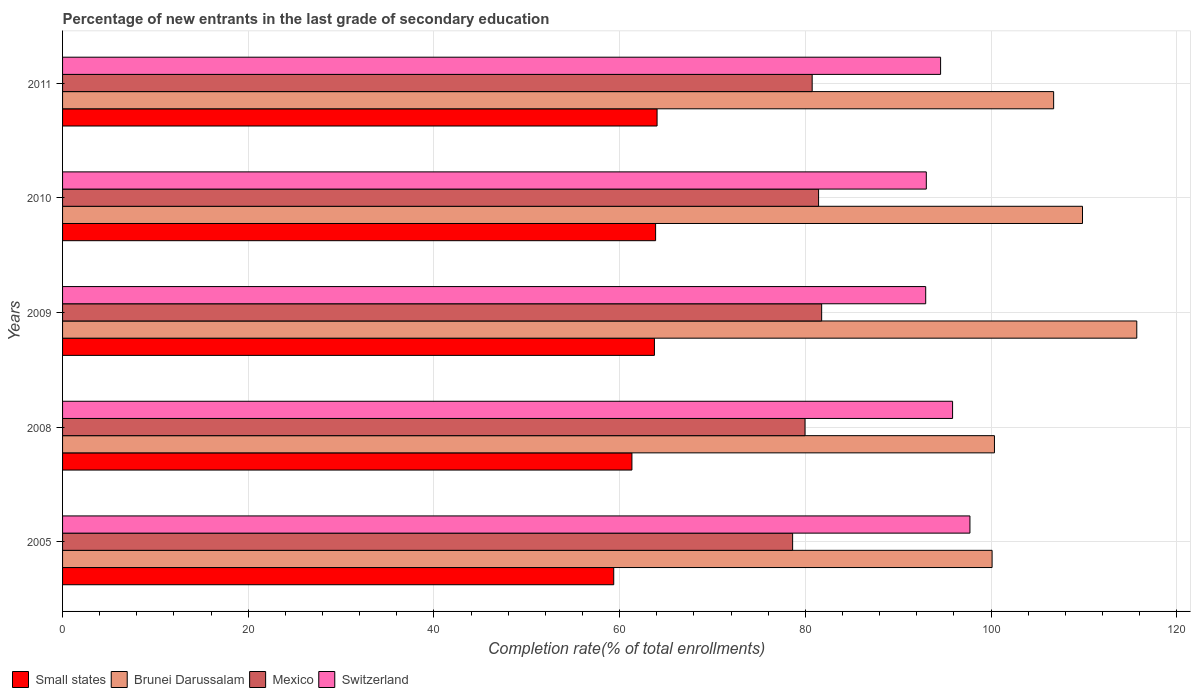How many groups of bars are there?
Give a very brief answer. 5. Are the number of bars on each tick of the Y-axis equal?
Your answer should be very brief. Yes. How many bars are there on the 1st tick from the top?
Your answer should be compact. 4. What is the label of the 3rd group of bars from the top?
Provide a short and direct response. 2009. What is the percentage of new entrants in Small states in 2011?
Your response must be concise. 64.03. Across all years, what is the maximum percentage of new entrants in Brunei Darussalam?
Give a very brief answer. 115.7. Across all years, what is the minimum percentage of new entrants in Switzerland?
Provide a short and direct response. 92.97. In which year was the percentage of new entrants in Switzerland maximum?
Ensure brevity in your answer.  2005. In which year was the percentage of new entrants in Switzerland minimum?
Keep it short and to the point. 2009. What is the total percentage of new entrants in Mexico in the graph?
Your answer should be very brief. 402.53. What is the difference between the percentage of new entrants in Switzerland in 2008 and that in 2011?
Your answer should be compact. 1.29. What is the difference between the percentage of new entrants in Switzerland in 2010 and the percentage of new entrants in Mexico in 2011?
Give a very brief answer. 12.29. What is the average percentage of new entrants in Small states per year?
Ensure brevity in your answer.  62.47. In the year 2009, what is the difference between the percentage of new entrants in Small states and percentage of new entrants in Brunei Darussalam?
Keep it short and to the point. -51.95. What is the ratio of the percentage of new entrants in Small states in 2009 to that in 2010?
Offer a very short reply. 1. Is the difference between the percentage of new entrants in Small states in 2005 and 2008 greater than the difference between the percentage of new entrants in Brunei Darussalam in 2005 and 2008?
Make the answer very short. No. What is the difference between the highest and the second highest percentage of new entrants in Switzerland?
Offer a very short reply. 1.87. What is the difference between the highest and the lowest percentage of new entrants in Small states?
Your answer should be compact. 4.67. In how many years, is the percentage of new entrants in Switzerland greater than the average percentage of new entrants in Switzerland taken over all years?
Ensure brevity in your answer.  2. Is the sum of the percentage of new entrants in Small states in 2009 and 2011 greater than the maximum percentage of new entrants in Switzerland across all years?
Offer a terse response. Yes. What does the 1st bar from the top in 2008 represents?
Offer a terse response. Switzerland. How many bars are there?
Your answer should be very brief. 20. Are all the bars in the graph horizontal?
Ensure brevity in your answer.  Yes. How many years are there in the graph?
Provide a succinct answer. 5. Are the values on the major ticks of X-axis written in scientific E-notation?
Your response must be concise. No. Does the graph contain any zero values?
Offer a terse response. No. Does the graph contain grids?
Offer a very short reply. Yes. How many legend labels are there?
Make the answer very short. 4. How are the legend labels stacked?
Ensure brevity in your answer.  Horizontal. What is the title of the graph?
Provide a succinct answer. Percentage of new entrants in the last grade of secondary education. What is the label or title of the X-axis?
Offer a very short reply. Completion rate(% of total enrollments). What is the Completion rate(% of total enrollments) in Small states in 2005?
Your answer should be compact. 59.36. What is the Completion rate(% of total enrollments) in Brunei Darussalam in 2005?
Your answer should be very brief. 100.12. What is the Completion rate(% of total enrollments) of Mexico in 2005?
Your response must be concise. 78.63. What is the Completion rate(% of total enrollments) of Switzerland in 2005?
Provide a succinct answer. 97.73. What is the Completion rate(% of total enrollments) in Small states in 2008?
Your response must be concise. 61.32. What is the Completion rate(% of total enrollments) in Brunei Darussalam in 2008?
Offer a very short reply. 100.37. What is the Completion rate(% of total enrollments) in Mexico in 2008?
Make the answer very short. 79.97. What is the Completion rate(% of total enrollments) of Switzerland in 2008?
Your answer should be compact. 95.86. What is the Completion rate(% of total enrollments) in Small states in 2009?
Your answer should be very brief. 63.75. What is the Completion rate(% of total enrollments) in Brunei Darussalam in 2009?
Make the answer very short. 115.7. What is the Completion rate(% of total enrollments) in Mexico in 2009?
Your answer should be very brief. 81.76. What is the Completion rate(% of total enrollments) in Switzerland in 2009?
Give a very brief answer. 92.97. What is the Completion rate(% of total enrollments) in Small states in 2010?
Make the answer very short. 63.88. What is the Completion rate(% of total enrollments) in Brunei Darussalam in 2010?
Offer a terse response. 109.86. What is the Completion rate(% of total enrollments) in Mexico in 2010?
Offer a very short reply. 81.43. What is the Completion rate(% of total enrollments) in Switzerland in 2010?
Your response must be concise. 93.03. What is the Completion rate(% of total enrollments) in Small states in 2011?
Provide a short and direct response. 64.03. What is the Completion rate(% of total enrollments) of Brunei Darussalam in 2011?
Give a very brief answer. 106.75. What is the Completion rate(% of total enrollments) of Mexico in 2011?
Provide a short and direct response. 80.74. What is the Completion rate(% of total enrollments) of Switzerland in 2011?
Give a very brief answer. 94.57. Across all years, what is the maximum Completion rate(% of total enrollments) in Small states?
Make the answer very short. 64.03. Across all years, what is the maximum Completion rate(% of total enrollments) in Brunei Darussalam?
Make the answer very short. 115.7. Across all years, what is the maximum Completion rate(% of total enrollments) in Mexico?
Your answer should be very brief. 81.76. Across all years, what is the maximum Completion rate(% of total enrollments) of Switzerland?
Your answer should be very brief. 97.73. Across all years, what is the minimum Completion rate(% of total enrollments) in Small states?
Your response must be concise. 59.36. Across all years, what is the minimum Completion rate(% of total enrollments) of Brunei Darussalam?
Offer a terse response. 100.12. Across all years, what is the minimum Completion rate(% of total enrollments) in Mexico?
Your answer should be compact. 78.63. Across all years, what is the minimum Completion rate(% of total enrollments) in Switzerland?
Provide a succinct answer. 92.97. What is the total Completion rate(% of total enrollments) in Small states in the graph?
Keep it short and to the point. 312.35. What is the total Completion rate(% of total enrollments) in Brunei Darussalam in the graph?
Provide a short and direct response. 532.79. What is the total Completion rate(% of total enrollments) of Mexico in the graph?
Keep it short and to the point. 402.53. What is the total Completion rate(% of total enrollments) of Switzerland in the graph?
Provide a succinct answer. 474.16. What is the difference between the Completion rate(% of total enrollments) of Small states in 2005 and that in 2008?
Provide a succinct answer. -1.96. What is the difference between the Completion rate(% of total enrollments) of Brunei Darussalam in 2005 and that in 2008?
Give a very brief answer. -0.25. What is the difference between the Completion rate(% of total enrollments) in Mexico in 2005 and that in 2008?
Provide a succinct answer. -1.34. What is the difference between the Completion rate(% of total enrollments) of Switzerland in 2005 and that in 2008?
Provide a succinct answer. 1.87. What is the difference between the Completion rate(% of total enrollments) in Small states in 2005 and that in 2009?
Offer a terse response. -4.38. What is the difference between the Completion rate(% of total enrollments) in Brunei Darussalam in 2005 and that in 2009?
Give a very brief answer. -15.58. What is the difference between the Completion rate(% of total enrollments) in Mexico in 2005 and that in 2009?
Keep it short and to the point. -3.13. What is the difference between the Completion rate(% of total enrollments) in Switzerland in 2005 and that in 2009?
Keep it short and to the point. 4.76. What is the difference between the Completion rate(% of total enrollments) in Small states in 2005 and that in 2010?
Make the answer very short. -4.51. What is the difference between the Completion rate(% of total enrollments) in Brunei Darussalam in 2005 and that in 2010?
Provide a succinct answer. -9.74. What is the difference between the Completion rate(% of total enrollments) in Mexico in 2005 and that in 2010?
Give a very brief answer. -2.8. What is the difference between the Completion rate(% of total enrollments) in Switzerland in 2005 and that in 2010?
Offer a very short reply. 4.7. What is the difference between the Completion rate(% of total enrollments) in Small states in 2005 and that in 2011?
Provide a succinct answer. -4.67. What is the difference between the Completion rate(% of total enrollments) of Brunei Darussalam in 2005 and that in 2011?
Your answer should be compact. -6.63. What is the difference between the Completion rate(% of total enrollments) in Mexico in 2005 and that in 2011?
Provide a succinct answer. -2.11. What is the difference between the Completion rate(% of total enrollments) in Switzerland in 2005 and that in 2011?
Offer a terse response. 3.16. What is the difference between the Completion rate(% of total enrollments) of Small states in 2008 and that in 2009?
Keep it short and to the point. -2.42. What is the difference between the Completion rate(% of total enrollments) of Brunei Darussalam in 2008 and that in 2009?
Offer a very short reply. -15.33. What is the difference between the Completion rate(% of total enrollments) of Mexico in 2008 and that in 2009?
Your answer should be very brief. -1.79. What is the difference between the Completion rate(% of total enrollments) in Switzerland in 2008 and that in 2009?
Ensure brevity in your answer.  2.9. What is the difference between the Completion rate(% of total enrollments) of Small states in 2008 and that in 2010?
Your response must be concise. -2.55. What is the difference between the Completion rate(% of total enrollments) of Brunei Darussalam in 2008 and that in 2010?
Make the answer very short. -9.48. What is the difference between the Completion rate(% of total enrollments) in Mexico in 2008 and that in 2010?
Your answer should be very brief. -1.46. What is the difference between the Completion rate(% of total enrollments) of Switzerland in 2008 and that in 2010?
Your answer should be very brief. 2.83. What is the difference between the Completion rate(% of total enrollments) of Small states in 2008 and that in 2011?
Provide a succinct answer. -2.71. What is the difference between the Completion rate(% of total enrollments) in Brunei Darussalam in 2008 and that in 2011?
Offer a terse response. -6.38. What is the difference between the Completion rate(% of total enrollments) in Mexico in 2008 and that in 2011?
Your answer should be compact. -0.77. What is the difference between the Completion rate(% of total enrollments) in Switzerland in 2008 and that in 2011?
Provide a succinct answer. 1.29. What is the difference between the Completion rate(% of total enrollments) in Small states in 2009 and that in 2010?
Your response must be concise. -0.13. What is the difference between the Completion rate(% of total enrollments) of Brunei Darussalam in 2009 and that in 2010?
Your answer should be compact. 5.85. What is the difference between the Completion rate(% of total enrollments) of Mexico in 2009 and that in 2010?
Keep it short and to the point. 0.33. What is the difference between the Completion rate(% of total enrollments) of Switzerland in 2009 and that in 2010?
Provide a succinct answer. -0.07. What is the difference between the Completion rate(% of total enrollments) of Small states in 2009 and that in 2011?
Keep it short and to the point. -0.28. What is the difference between the Completion rate(% of total enrollments) of Brunei Darussalam in 2009 and that in 2011?
Your response must be concise. 8.95. What is the difference between the Completion rate(% of total enrollments) of Mexico in 2009 and that in 2011?
Ensure brevity in your answer.  1.02. What is the difference between the Completion rate(% of total enrollments) in Switzerland in 2009 and that in 2011?
Keep it short and to the point. -1.61. What is the difference between the Completion rate(% of total enrollments) of Small states in 2010 and that in 2011?
Provide a succinct answer. -0.16. What is the difference between the Completion rate(% of total enrollments) of Brunei Darussalam in 2010 and that in 2011?
Offer a terse response. 3.11. What is the difference between the Completion rate(% of total enrollments) of Mexico in 2010 and that in 2011?
Provide a succinct answer. 0.69. What is the difference between the Completion rate(% of total enrollments) in Switzerland in 2010 and that in 2011?
Offer a terse response. -1.54. What is the difference between the Completion rate(% of total enrollments) of Small states in 2005 and the Completion rate(% of total enrollments) of Brunei Darussalam in 2008?
Provide a succinct answer. -41.01. What is the difference between the Completion rate(% of total enrollments) of Small states in 2005 and the Completion rate(% of total enrollments) of Mexico in 2008?
Offer a terse response. -20.6. What is the difference between the Completion rate(% of total enrollments) of Small states in 2005 and the Completion rate(% of total enrollments) of Switzerland in 2008?
Keep it short and to the point. -36.5. What is the difference between the Completion rate(% of total enrollments) in Brunei Darussalam in 2005 and the Completion rate(% of total enrollments) in Mexico in 2008?
Your response must be concise. 20.15. What is the difference between the Completion rate(% of total enrollments) of Brunei Darussalam in 2005 and the Completion rate(% of total enrollments) of Switzerland in 2008?
Provide a succinct answer. 4.26. What is the difference between the Completion rate(% of total enrollments) of Mexico in 2005 and the Completion rate(% of total enrollments) of Switzerland in 2008?
Offer a terse response. -17.23. What is the difference between the Completion rate(% of total enrollments) in Small states in 2005 and the Completion rate(% of total enrollments) in Brunei Darussalam in 2009?
Provide a succinct answer. -56.34. What is the difference between the Completion rate(% of total enrollments) in Small states in 2005 and the Completion rate(% of total enrollments) in Mexico in 2009?
Provide a short and direct response. -22.4. What is the difference between the Completion rate(% of total enrollments) in Small states in 2005 and the Completion rate(% of total enrollments) in Switzerland in 2009?
Your response must be concise. -33.6. What is the difference between the Completion rate(% of total enrollments) of Brunei Darussalam in 2005 and the Completion rate(% of total enrollments) of Mexico in 2009?
Your answer should be compact. 18.36. What is the difference between the Completion rate(% of total enrollments) in Brunei Darussalam in 2005 and the Completion rate(% of total enrollments) in Switzerland in 2009?
Your answer should be compact. 7.15. What is the difference between the Completion rate(% of total enrollments) of Mexico in 2005 and the Completion rate(% of total enrollments) of Switzerland in 2009?
Provide a short and direct response. -14.33. What is the difference between the Completion rate(% of total enrollments) of Small states in 2005 and the Completion rate(% of total enrollments) of Brunei Darussalam in 2010?
Give a very brief answer. -50.49. What is the difference between the Completion rate(% of total enrollments) in Small states in 2005 and the Completion rate(% of total enrollments) in Mexico in 2010?
Keep it short and to the point. -22.06. What is the difference between the Completion rate(% of total enrollments) of Small states in 2005 and the Completion rate(% of total enrollments) of Switzerland in 2010?
Your answer should be compact. -33.67. What is the difference between the Completion rate(% of total enrollments) of Brunei Darussalam in 2005 and the Completion rate(% of total enrollments) of Mexico in 2010?
Provide a short and direct response. 18.69. What is the difference between the Completion rate(% of total enrollments) of Brunei Darussalam in 2005 and the Completion rate(% of total enrollments) of Switzerland in 2010?
Ensure brevity in your answer.  7.08. What is the difference between the Completion rate(% of total enrollments) in Mexico in 2005 and the Completion rate(% of total enrollments) in Switzerland in 2010?
Provide a short and direct response. -14.4. What is the difference between the Completion rate(% of total enrollments) in Small states in 2005 and the Completion rate(% of total enrollments) in Brunei Darussalam in 2011?
Provide a succinct answer. -47.38. What is the difference between the Completion rate(% of total enrollments) of Small states in 2005 and the Completion rate(% of total enrollments) of Mexico in 2011?
Your response must be concise. -21.37. What is the difference between the Completion rate(% of total enrollments) in Small states in 2005 and the Completion rate(% of total enrollments) in Switzerland in 2011?
Offer a very short reply. -35.21. What is the difference between the Completion rate(% of total enrollments) in Brunei Darussalam in 2005 and the Completion rate(% of total enrollments) in Mexico in 2011?
Provide a short and direct response. 19.38. What is the difference between the Completion rate(% of total enrollments) in Brunei Darussalam in 2005 and the Completion rate(% of total enrollments) in Switzerland in 2011?
Provide a short and direct response. 5.55. What is the difference between the Completion rate(% of total enrollments) of Mexico in 2005 and the Completion rate(% of total enrollments) of Switzerland in 2011?
Offer a very short reply. -15.94. What is the difference between the Completion rate(% of total enrollments) of Small states in 2008 and the Completion rate(% of total enrollments) of Brunei Darussalam in 2009?
Your answer should be very brief. -54.38. What is the difference between the Completion rate(% of total enrollments) of Small states in 2008 and the Completion rate(% of total enrollments) of Mexico in 2009?
Offer a terse response. -20.44. What is the difference between the Completion rate(% of total enrollments) of Small states in 2008 and the Completion rate(% of total enrollments) of Switzerland in 2009?
Your answer should be very brief. -31.64. What is the difference between the Completion rate(% of total enrollments) in Brunei Darussalam in 2008 and the Completion rate(% of total enrollments) in Mexico in 2009?
Your answer should be very brief. 18.61. What is the difference between the Completion rate(% of total enrollments) of Brunei Darussalam in 2008 and the Completion rate(% of total enrollments) of Switzerland in 2009?
Ensure brevity in your answer.  7.41. What is the difference between the Completion rate(% of total enrollments) in Mexico in 2008 and the Completion rate(% of total enrollments) in Switzerland in 2009?
Your answer should be compact. -13. What is the difference between the Completion rate(% of total enrollments) of Small states in 2008 and the Completion rate(% of total enrollments) of Brunei Darussalam in 2010?
Provide a short and direct response. -48.53. What is the difference between the Completion rate(% of total enrollments) of Small states in 2008 and the Completion rate(% of total enrollments) of Mexico in 2010?
Make the answer very short. -20.1. What is the difference between the Completion rate(% of total enrollments) of Small states in 2008 and the Completion rate(% of total enrollments) of Switzerland in 2010?
Keep it short and to the point. -31.71. What is the difference between the Completion rate(% of total enrollments) in Brunei Darussalam in 2008 and the Completion rate(% of total enrollments) in Mexico in 2010?
Your answer should be compact. 18.94. What is the difference between the Completion rate(% of total enrollments) of Brunei Darussalam in 2008 and the Completion rate(% of total enrollments) of Switzerland in 2010?
Offer a very short reply. 7.34. What is the difference between the Completion rate(% of total enrollments) in Mexico in 2008 and the Completion rate(% of total enrollments) in Switzerland in 2010?
Provide a succinct answer. -13.06. What is the difference between the Completion rate(% of total enrollments) of Small states in 2008 and the Completion rate(% of total enrollments) of Brunei Darussalam in 2011?
Give a very brief answer. -45.42. What is the difference between the Completion rate(% of total enrollments) of Small states in 2008 and the Completion rate(% of total enrollments) of Mexico in 2011?
Ensure brevity in your answer.  -19.41. What is the difference between the Completion rate(% of total enrollments) of Small states in 2008 and the Completion rate(% of total enrollments) of Switzerland in 2011?
Your answer should be very brief. -33.25. What is the difference between the Completion rate(% of total enrollments) in Brunei Darussalam in 2008 and the Completion rate(% of total enrollments) in Mexico in 2011?
Offer a terse response. 19.63. What is the difference between the Completion rate(% of total enrollments) of Brunei Darussalam in 2008 and the Completion rate(% of total enrollments) of Switzerland in 2011?
Provide a succinct answer. 5.8. What is the difference between the Completion rate(% of total enrollments) of Mexico in 2008 and the Completion rate(% of total enrollments) of Switzerland in 2011?
Ensure brevity in your answer.  -14.6. What is the difference between the Completion rate(% of total enrollments) of Small states in 2009 and the Completion rate(% of total enrollments) of Brunei Darussalam in 2010?
Offer a terse response. -46.11. What is the difference between the Completion rate(% of total enrollments) of Small states in 2009 and the Completion rate(% of total enrollments) of Mexico in 2010?
Your answer should be compact. -17.68. What is the difference between the Completion rate(% of total enrollments) in Small states in 2009 and the Completion rate(% of total enrollments) in Switzerland in 2010?
Provide a short and direct response. -29.28. What is the difference between the Completion rate(% of total enrollments) of Brunei Darussalam in 2009 and the Completion rate(% of total enrollments) of Mexico in 2010?
Offer a terse response. 34.27. What is the difference between the Completion rate(% of total enrollments) in Brunei Darussalam in 2009 and the Completion rate(% of total enrollments) in Switzerland in 2010?
Your answer should be compact. 22.67. What is the difference between the Completion rate(% of total enrollments) in Mexico in 2009 and the Completion rate(% of total enrollments) in Switzerland in 2010?
Offer a very short reply. -11.27. What is the difference between the Completion rate(% of total enrollments) of Small states in 2009 and the Completion rate(% of total enrollments) of Brunei Darussalam in 2011?
Your answer should be very brief. -43. What is the difference between the Completion rate(% of total enrollments) of Small states in 2009 and the Completion rate(% of total enrollments) of Mexico in 2011?
Keep it short and to the point. -16.99. What is the difference between the Completion rate(% of total enrollments) in Small states in 2009 and the Completion rate(% of total enrollments) in Switzerland in 2011?
Provide a succinct answer. -30.82. What is the difference between the Completion rate(% of total enrollments) of Brunei Darussalam in 2009 and the Completion rate(% of total enrollments) of Mexico in 2011?
Keep it short and to the point. 34.96. What is the difference between the Completion rate(% of total enrollments) in Brunei Darussalam in 2009 and the Completion rate(% of total enrollments) in Switzerland in 2011?
Provide a short and direct response. 21.13. What is the difference between the Completion rate(% of total enrollments) of Mexico in 2009 and the Completion rate(% of total enrollments) of Switzerland in 2011?
Ensure brevity in your answer.  -12.81. What is the difference between the Completion rate(% of total enrollments) in Small states in 2010 and the Completion rate(% of total enrollments) in Brunei Darussalam in 2011?
Your answer should be very brief. -42.87. What is the difference between the Completion rate(% of total enrollments) of Small states in 2010 and the Completion rate(% of total enrollments) of Mexico in 2011?
Provide a succinct answer. -16.86. What is the difference between the Completion rate(% of total enrollments) in Small states in 2010 and the Completion rate(% of total enrollments) in Switzerland in 2011?
Give a very brief answer. -30.7. What is the difference between the Completion rate(% of total enrollments) in Brunei Darussalam in 2010 and the Completion rate(% of total enrollments) in Mexico in 2011?
Provide a succinct answer. 29.12. What is the difference between the Completion rate(% of total enrollments) in Brunei Darussalam in 2010 and the Completion rate(% of total enrollments) in Switzerland in 2011?
Provide a succinct answer. 15.28. What is the difference between the Completion rate(% of total enrollments) in Mexico in 2010 and the Completion rate(% of total enrollments) in Switzerland in 2011?
Provide a succinct answer. -13.14. What is the average Completion rate(% of total enrollments) of Small states per year?
Offer a terse response. 62.47. What is the average Completion rate(% of total enrollments) in Brunei Darussalam per year?
Make the answer very short. 106.56. What is the average Completion rate(% of total enrollments) in Mexico per year?
Your response must be concise. 80.51. What is the average Completion rate(% of total enrollments) in Switzerland per year?
Give a very brief answer. 94.83. In the year 2005, what is the difference between the Completion rate(% of total enrollments) in Small states and Completion rate(% of total enrollments) in Brunei Darussalam?
Make the answer very short. -40.75. In the year 2005, what is the difference between the Completion rate(% of total enrollments) in Small states and Completion rate(% of total enrollments) in Mexico?
Your answer should be very brief. -19.27. In the year 2005, what is the difference between the Completion rate(% of total enrollments) of Small states and Completion rate(% of total enrollments) of Switzerland?
Provide a short and direct response. -38.37. In the year 2005, what is the difference between the Completion rate(% of total enrollments) of Brunei Darussalam and Completion rate(% of total enrollments) of Mexico?
Offer a very short reply. 21.48. In the year 2005, what is the difference between the Completion rate(% of total enrollments) of Brunei Darussalam and Completion rate(% of total enrollments) of Switzerland?
Your response must be concise. 2.39. In the year 2005, what is the difference between the Completion rate(% of total enrollments) in Mexico and Completion rate(% of total enrollments) in Switzerland?
Your answer should be compact. -19.1. In the year 2008, what is the difference between the Completion rate(% of total enrollments) of Small states and Completion rate(% of total enrollments) of Brunei Darussalam?
Give a very brief answer. -39.05. In the year 2008, what is the difference between the Completion rate(% of total enrollments) in Small states and Completion rate(% of total enrollments) in Mexico?
Your response must be concise. -18.65. In the year 2008, what is the difference between the Completion rate(% of total enrollments) of Small states and Completion rate(% of total enrollments) of Switzerland?
Ensure brevity in your answer.  -34.54. In the year 2008, what is the difference between the Completion rate(% of total enrollments) of Brunei Darussalam and Completion rate(% of total enrollments) of Mexico?
Your answer should be very brief. 20.4. In the year 2008, what is the difference between the Completion rate(% of total enrollments) in Brunei Darussalam and Completion rate(% of total enrollments) in Switzerland?
Your answer should be very brief. 4.51. In the year 2008, what is the difference between the Completion rate(% of total enrollments) in Mexico and Completion rate(% of total enrollments) in Switzerland?
Ensure brevity in your answer.  -15.89. In the year 2009, what is the difference between the Completion rate(% of total enrollments) of Small states and Completion rate(% of total enrollments) of Brunei Darussalam?
Your answer should be compact. -51.95. In the year 2009, what is the difference between the Completion rate(% of total enrollments) in Small states and Completion rate(% of total enrollments) in Mexico?
Offer a very short reply. -18.01. In the year 2009, what is the difference between the Completion rate(% of total enrollments) of Small states and Completion rate(% of total enrollments) of Switzerland?
Offer a terse response. -29.22. In the year 2009, what is the difference between the Completion rate(% of total enrollments) of Brunei Darussalam and Completion rate(% of total enrollments) of Mexico?
Your answer should be compact. 33.94. In the year 2009, what is the difference between the Completion rate(% of total enrollments) of Brunei Darussalam and Completion rate(% of total enrollments) of Switzerland?
Keep it short and to the point. 22.74. In the year 2009, what is the difference between the Completion rate(% of total enrollments) in Mexico and Completion rate(% of total enrollments) in Switzerland?
Keep it short and to the point. -11.21. In the year 2010, what is the difference between the Completion rate(% of total enrollments) in Small states and Completion rate(% of total enrollments) in Brunei Darussalam?
Provide a succinct answer. -45.98. In the year 2010, what is the difference between the Completion rate(% of total enrollments) of Small states and Completion rate(% of total enrollments) of Mexico?
Offer a very short reply. -17.55. In the year 2010, what is the difference between the Completion rate(% of total enrollments) in Small states and Completion rate(% of total enrollments) in Switzerland?
Provide a short and direct response. -29.16. In the year 2010, what is the difference between the Completion rate(% of total enrollments) in Brunei Darussalam and Completion rate(% of total enrollments) in Mexico?
Give a very brief answer. 28.43. In the year 2010, what is the difference between the Completion rate(% of total enrollments) in Brunei Darussalam and Completion rate(% of total enrollments) in Switzerland?
Make the answer very short. 16.82. In the year 2010, what is the difference between the Completion rate(% of total enrollments) of Mexico and Completion rate(% of total enrollments) of Switzerland?
Offer a terse response. -11.6. In the year 2011, what is the difference between the Completion rate(% of total enrollments) of Small states and Completion rate(% of total enrollments) of Brunei Darussalam?
Provide a short and direct response. -42.71. In the year 2011, what is the difference between the Completion rate(% of total enrollments) in Small states and Completion rate(% of total enrollments) in Mexico?
Give a very brief answer. -16.71. In the year 2011, what is the difference between the Completion rate(% of total enrollments) in Small states and Completion rate(% of total enrollments) in Switzerland?
Your response must be concise. -30.54. In the year 2011, what is the difference between the Completion rate(% of total enrollments) of Brunei Darussalam and Completion rate(% of total enrollments) of Mexico?
Ensure brevity in your answer.  26.01. In the year 2011, what is the difference between the Completion rate(% of total enrollments) of Brunei Darussalam and Completion rate(% of total enrollments) of Switzerland?
Provide a succinct answer. 12.18. In the year 2011, what is the difference between the Completion rate(% of total enrollments) in Mexico and Completion rate(% of total enrollments) in Switzerland?
Make the answer very short. -13.83. What is the ratio of the Completion rate(% of total enrollments) in Small states in 2005 to that in 2008?
Keep it short and to the point. 0.97. What is the ratio of the Completion rate(% of total enrollments) in Brunei Darussalam in 2005 to that in 2008?
Your answer should be compact. 1. What is the ratio of the Completion rate(% of total enrollments) in Mexico in 2005 to that in 2008?
Your answer should be very brief. 0.98. What is the ratio of the Completion rate(% of total enrollments) of Switzerland in 2005 to that in 2008?
Offer a very short reply. 1.02. What is the ratio of the Completion rate(% of total enrollments) of Small states in 2005 to that in 2009?
Your answer should be compact. 0.93. What is the ratio of the Completion rate(% of total enrollments) in Brunei Darussalam in 2005 to that in 2009?
Offer a terse response. 0.87. What is the ratio of the Completion rate(% of total enrollments) of Mexico in 2005 to that in 2009?
Make the answer very short. 0.96. What is the ratio of the Completion rate(% of total enrollments) of Switzerland in 2005 to that in 2009?
Your answer should be very brief. 1.05. What is the ratio of the Completion rate(% of total enrollments) of Small states in 2005 to that in 2010?
Your answer should be compact. 0.93. What is the ratio of the Completion rate(% of total enrollments) in Brunei Darussalam in 2005 to that in 2010?
Ensure brevity in your answer.  0.91. What is the ratio of the Completion rate(% of total enrollments) of Mexico in 2005 to that in 2010?
Your response must be concise. 0.97. What is the ratio of the Completion rate(% of total enrollments) of Switzerland in 2005 to that in 2010?
Your response must be concise. 1.05. What is the ratio of the Completion rate(% of total enrollments) of Small states in 2005 to that in 2011?
Ensure brevity in your answer.  0.93. What is the ratio of the Completion rate(% of total enrollments) in Brunei Darussalam in 2005 to that in 2011?
Offer a very short reply. 0.94. What is the ratio of the Completion rate(% of total enrollments) of Mexico in 2005 to that in 2011?
Offer a very short reply. 0.97. What is the ratio of the Completion rate(% of total enrollments) of Switzerland in 2005 to that in 2011?
Provide a short and direct response. 1.03. What is the ratio of the Completion rate(% of total enrollments) of Small states in 2008 to that in 2009?
Make the answer very short. 0.96. What is the ratio of the Completion rate(% of total enrollments) of Brunei Darussalam in 2008 to that in 2009?
Keep it short and to the point. 0.87. What is the ratio of the Completion rate(% of total enrollments) of Mexico in 2008 to that in 2009?
Offer a terse response. 0.98. What is the ratio of the Completion rate(% of total enrollments) of Switzerland in 2008 to that in 2009?
Provide a succinct answer. 1.03. What is the ratio of the Completion rate(% of total enrollments) in Small states in 2008 to that in 2010?
Make the answer very short. 0.96. What is the ratio of the Completion rate(% of total enrollments) in Brunei Darussalam in 2008 to that in 2010?
Make the answer very short. 0.91. What is the ratio of the Completion rate(% of total enrollments) of Mexico in 2008 to that in 2010?
Give a very brief answer. 0.98. What is the ratio of the Completion rate(% of total enrollments) of Switzerland in 2008 to that in 2010?
Keep it short and to the point. 1.03. What is the ratio of the Completion rate(% of total enrollments) in Small states in 2008 to that in 2011?
Your answer should be compact. 0.96. What is the ratio of the Completion rate(% of total enrollments) in Brunei Darussalam in 2008 to that in 2011?
Keep it short and to the point. 0.94. What is the ratio of the Completion rate(% of total enrollments) in Mexico in 2008 to that in 2011?
Your response must be concise. 0.99. What is the ratio of the Completion rate(% of total enrollments) in Switzerland in 2008 to that in 2011?
Offer a very short reply. 1.01. What is the ratio of the Completion rate(% of total enrollments) of Small states in 2009 to that in 2010?
Offer a terse response. 1. What is the ratio of the Completion rate(% of total enrollments) in Brunei Darussalam in 2009 to that in 2010?
Your answer should be very brief. 1.05. What is the ratio of the Completion rate(% of total enrollments) in Brunei Darussalam in 2009 to that in 2011?
Ensure brevity in your answer.  1.08. What is the ratio of the Completion rate(% of total enrollments) in Mexico in 2009 to that in 2011?
Give a very brief answer. 1.01. What is the ratio of the Completion rate(% of total enrollments) in Small states in 2010 to that in 2011?
Provide a succinct answer. 1. What is the ratio of the Completion rate(% of total enrollments) of Brunei Darussalam in 2010 to that in 2011?
Ensure brevity in your answer.  1.03. What is the ratio of the Completion rate(% of total enrollments) of Mexico in 2010 to that in 2011?
Your answer should be compact. 1.01. What is the ratio of the Completion rate(% of total enrollments) of Switzerland in 2010 to that in 2011?
Ensure brevity in your answer.  0.98. What is the difference between the highest and the second highest Completion rate(% of total enrollments) of Small states?
Provide a short and direct response. 0.16. What is the difference between the highest and the second highest Completion rate(% of total enrollments) in Brunei Darussalam?
Your answer should be compact. 5.85. What is the difference between the highest and the second highest Completion rate(% of total enrollments) in Mexico?
Make the answer very short. 0.33. What is the difference between the highest and the second highest Completion rate(% of total enrollments) of Switzerland?
Your answer should be very brief. 1.87. What is the difference between the highest and the lowest Completion rate(% of total enrollments) in Small states?
Your answer should be very brief. 4.67. What is the difference between the highest and the lowest Completion rate(% of total enrollments) of Brunei Darussalam?
Give a very brief answer. 15.58. What is the difference between the highest and the lowest Completion rate(% of total enrollments) in Mexico?
Offer a terse response. 3.13. What is the difference between the highest and the lowest Completion rate(% of total enrollments) of Switzerland?
Your answer should be compact. 4.76. 